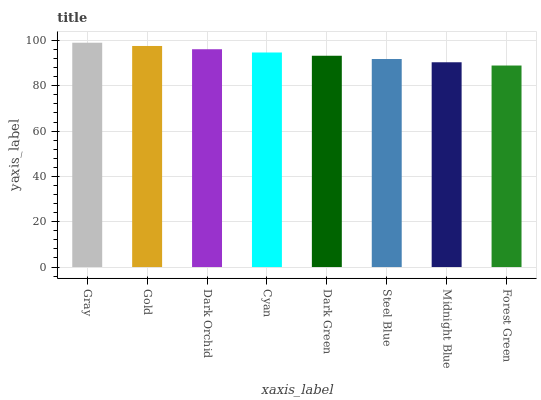Is Gold the minimum?
Answer yes or no. No. Is Gold the maximum?
Answer yes or no. No. Is Gray greater than Gold?
Answer yes or no. Yes. Is Gold less than Gray?
Answer yes or no. Yes. Is Gold greater than Gray?
Answer yes or no. No. Is Gray less than Gold?
Answer yes or no. No. Is Cyan the high median?
Answer yes or no. Yes. Is Dark Green the low median?
Answer yes or no. Yes. Is Gold the high median?
Answer yes or no. No. Is Cyan the low median?
Answer yes or no. No. 